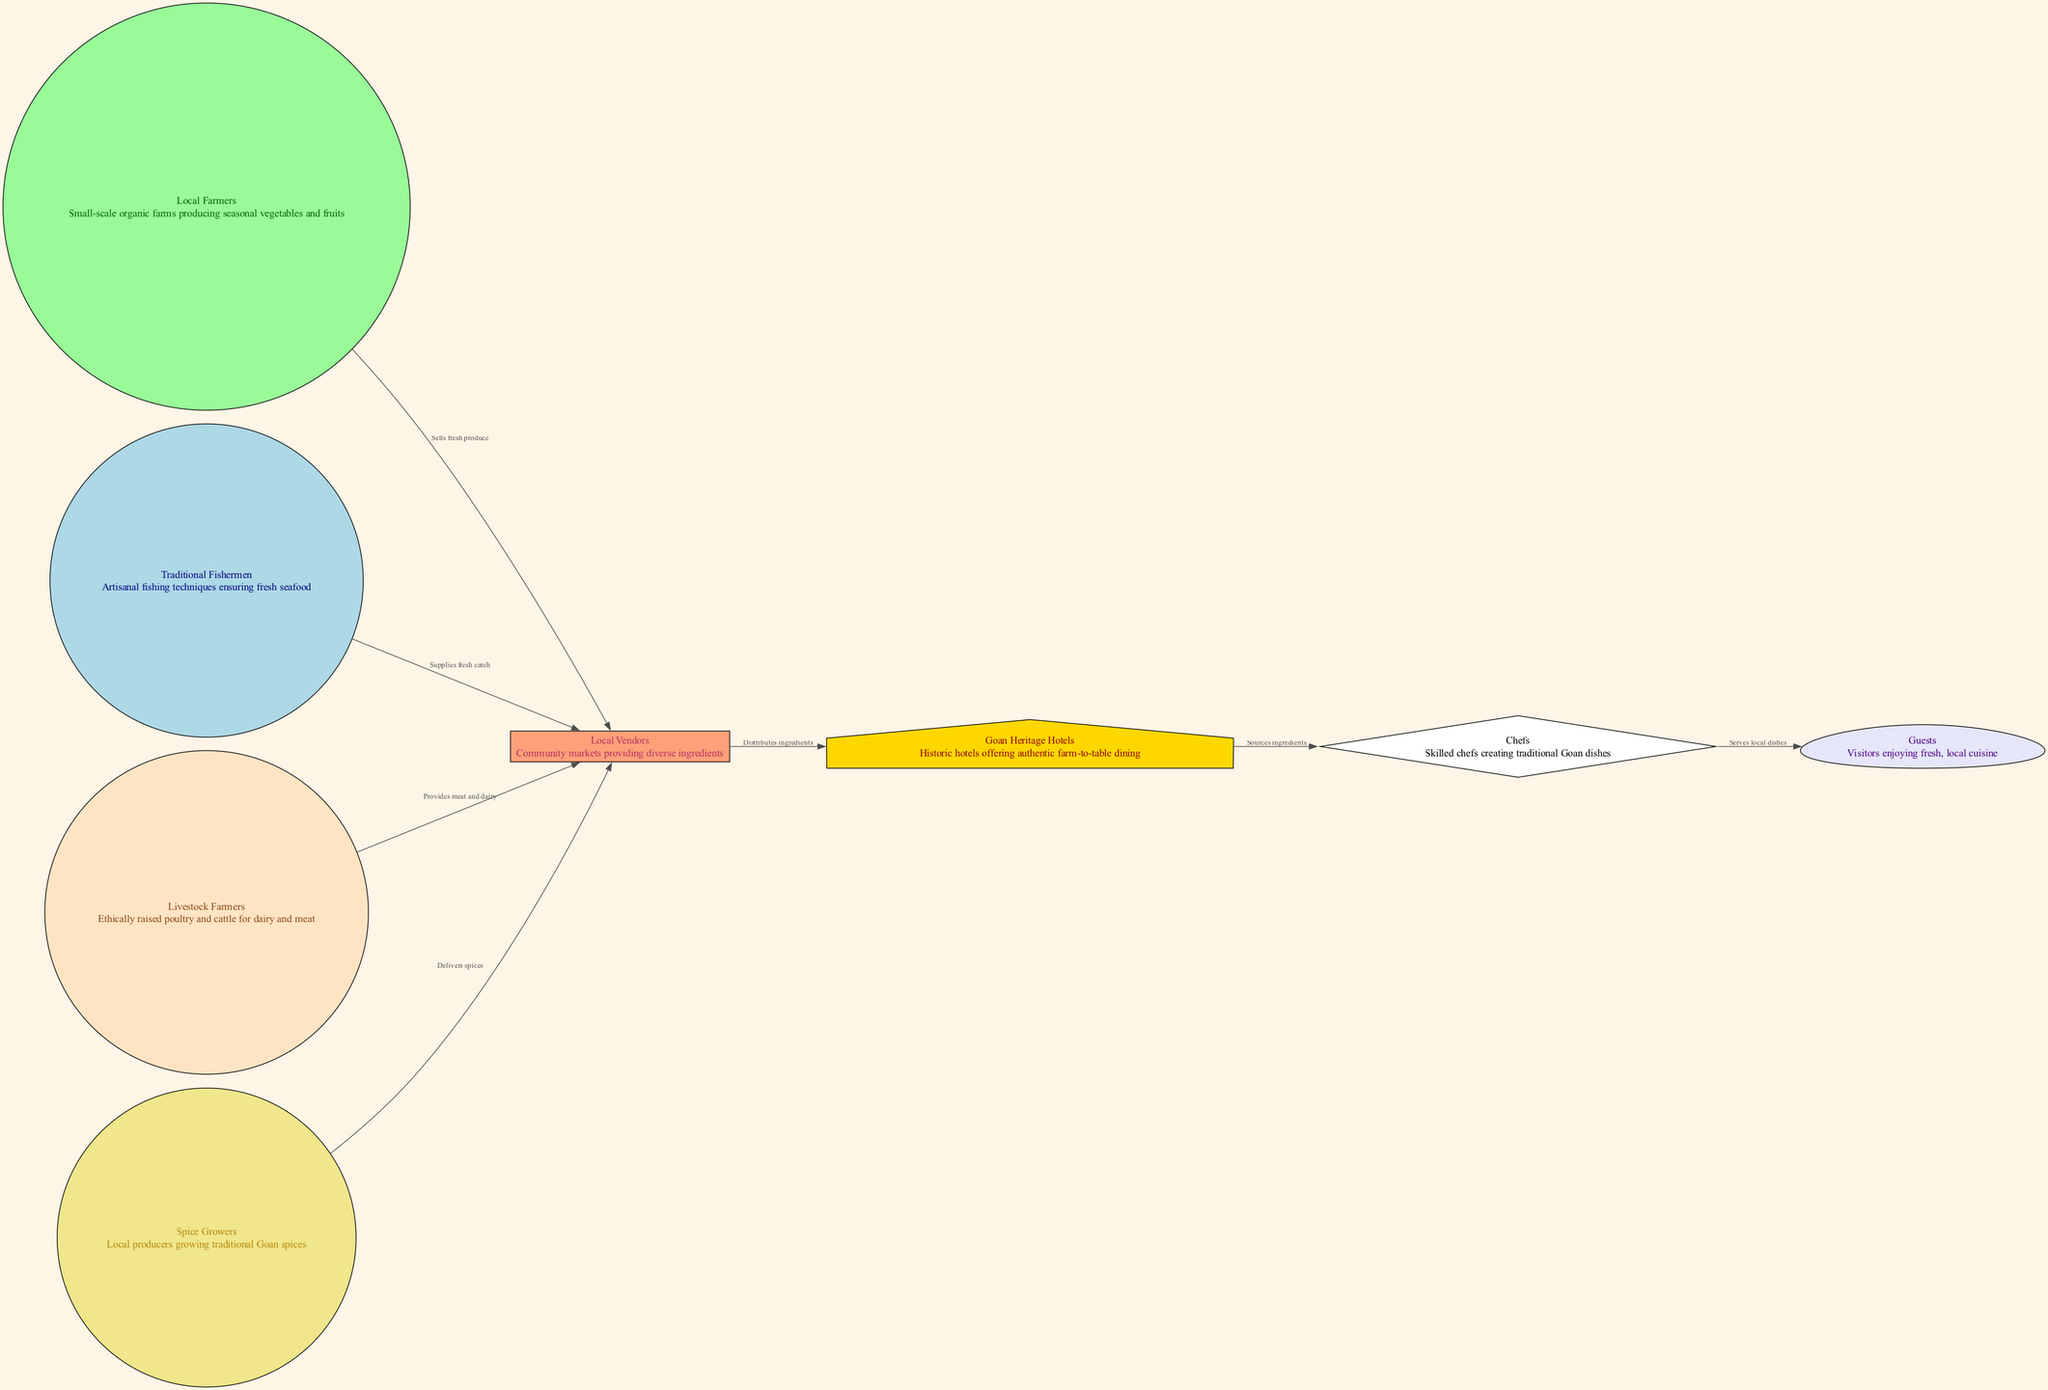What are the main sources of ingredients for Goan Heritage Hotels? The main sources of ingredients are local farmers, traditional fishermen, livestock farmers, and spice growers. Each of these groups contributes specific items, such as vegetables, seafood, meat, and spices, respectively.
Answer: Local farmers, traditional fishermen, livestock farmers, spice growers How many nodes are there in the diagram? By counting the unique entities represented in the diagram, we find that there are eight nodes: local farmers, traditional fishermen, livestock farmers, spice growers, local vendors, Goan heritage hotels, chefs, and guests.
Answer: Eight What role do local vendors play in the food chain? Local vendors act as intermediaries that distribute ingredients sourced from farmers, fishermen, livestock farmers, and spice growers to heritage hotels, thus facilitating access to fresh produce and local products.
Answer: Distributes ingredients Which node serves local dishes to guests? The chefs prepare and serve local dishes to the guests, utilizing ingredients they source from the Goan heritage hotels, which in turn receive ingredients from local vendors.
Answer: Chefs How many edges are there connecting farmers and vendors? There are four edges connecting farmers to vendors: one from local farmers, one from traditional fishermen, one from livestock farmers, and one from spice growers. Each edge indicates a specific type of ingredient being supplied.
Answer: Four What is the relationship between local vendors and Goan heritage hotels? Local vendors distribute ingredients to Goan heritage hotels, which source their ingredients primarily from these vendors for their farm-to-table dining options.
Answer: Distributes ingredients Which group provides fresh seafood? The group responsible for supplying fresh seafood is the traditional fishermen. They use artisanal techniques to ensure quality and freshness in their catch.
Answer: Traditional fishermen How does the ingredients flow from farmers to guests? The flow starts with local farmers producing fresh produce, which is sold to local vendors. Vendors distribute the ingredients to Goan heritage hotels, where chefs prepare the dishes that are ultimately served to guests.
Answer: Local farmers → Vendors → Goan heritage hotels → Chefs → Guests What type of farming do livestock farmers engage in? Livestock farmers engage in ethical farming practices, raising poultry and cattle for meat and dairy production. This is important for ensuring quality and humane treatment.
Answer: Ethically raised poultry and cattle 